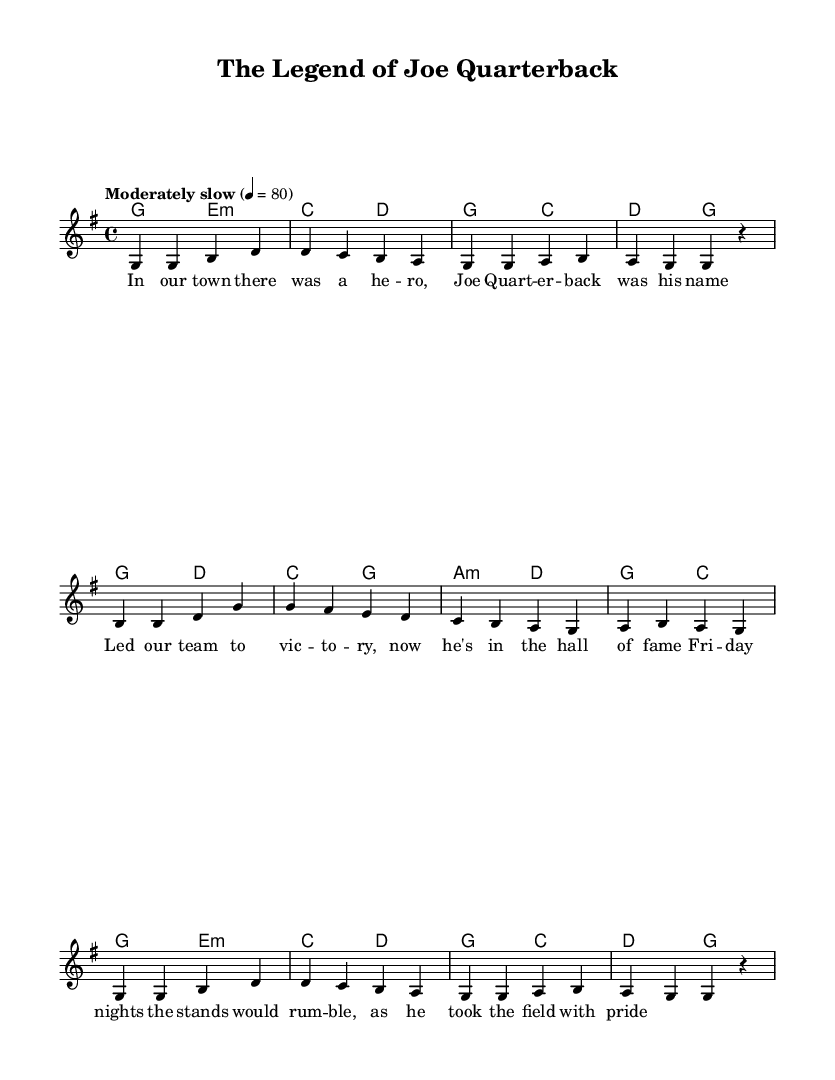What is the key signature of this music? The key signature is determined by looking at the number of sharps or flats at the beginning of the staff. In this sheet music, the key signature indicates G major, which has one sharp (F#).
Answer: G major What is the time signature of this music? The time signature is found at the beginning of the staff and indicates how many beats are in each measure. Here, the time signature is 4/4, meaning there are four beats per measure.
Answer: 4/4 What is the tempo marking for this piece? The tempo marking is indicated above the staff in the form of a descriptive phrase. In this sheet music, it states "Moderately slow" and specifies a metronome marking of 80 beats per minute.
Answer: Moderately slow How many measures are in the melody section? To determine the number of measures, you can count the groupings of notes separated by vertical lines. The melody section consists of 8 measures in total.
Answer: 8 What is the first lyric line of the song? The first lyric line is found directly below the staff, aligned with the corresponding notes. The first line reads: "In our town there was a he -- ro, Joe Quart -- er -- back was his name."
Answer: In our town there was a he -- ro, Joe Quart -- er -- back was his name What type of chord is the first chord in the harmony section? The first chord can be identified by the letter name and the quality indicated in the chord symbols. The first chord in the harmony section is G major, as noted by the letter "g".
Answer: G major What is the subject of the lyrics in this folk ballad? The subject of the lyrics can be discerned from the content of the text provided; it tells the story of a hometown hero, specifically a quarterback named Joe.
Answer: Hometown hero 